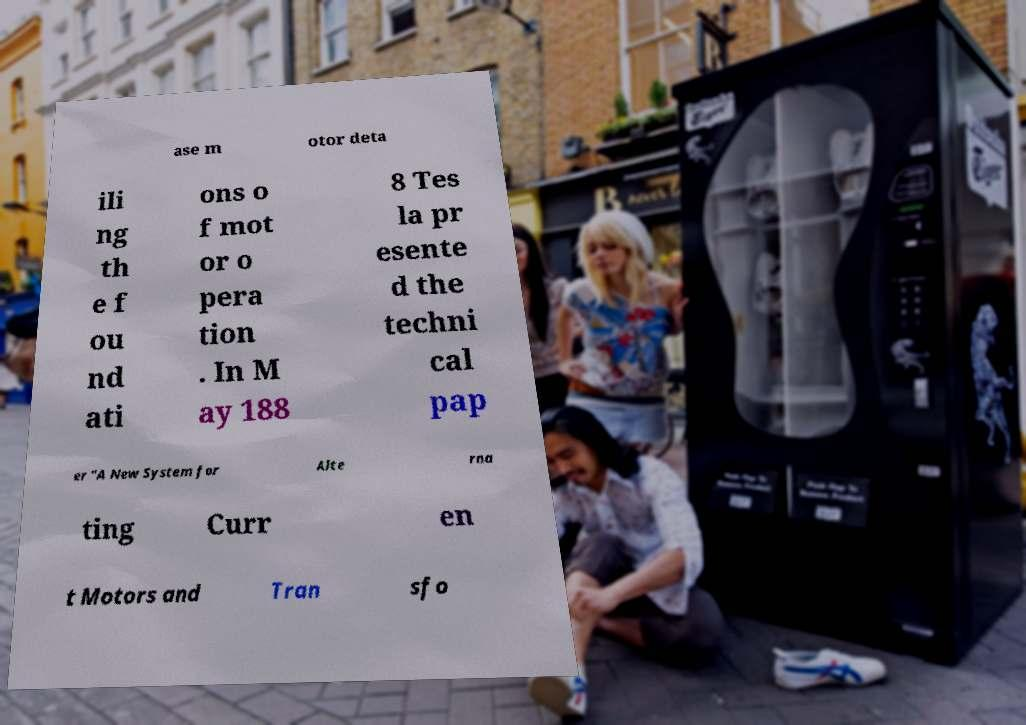Can you read and provide the text displayed in the image?This photo seems to have some interesting text. Can you extract and type it out for me? ase m otor deta ili ng th e f ou nd ati ons o f mot or o pera tion . In M ay 188 8 Tes la pr esente d the techni cal pap er "A New System for Alte rna ting Curr en t Motors and Tran sfo 